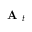<formula> <loc_0><loc_0><loc_500><loc_500>A _ { t }</formula> 